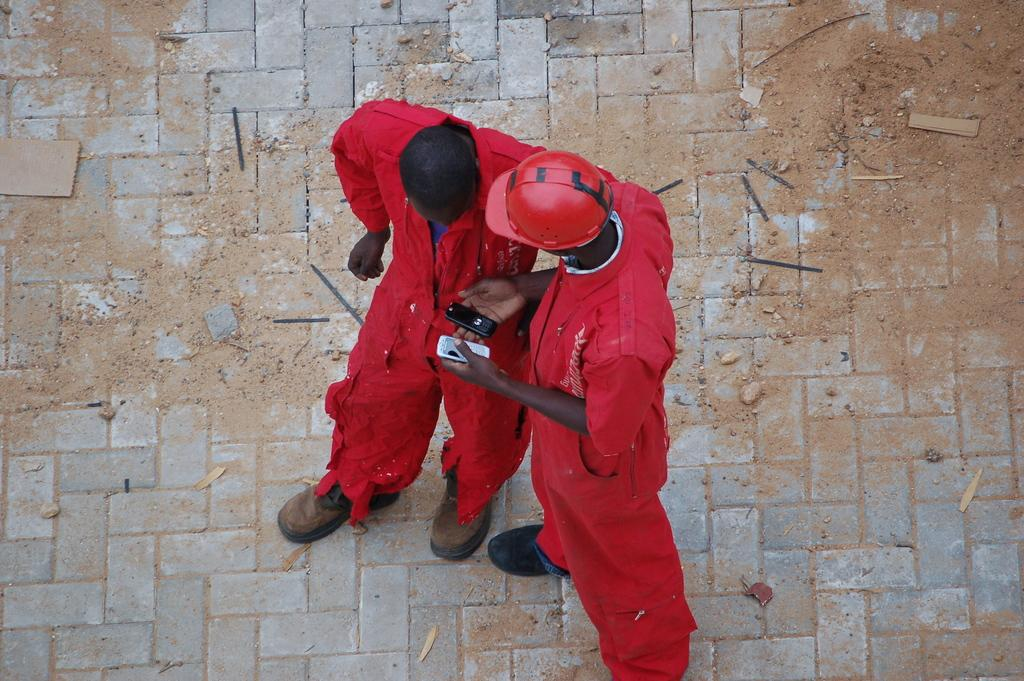How many people are in the image? There are two people in the image. What are the people doing in the image? The people are standing on a surface. Can you describe any objects that one of the people is holding? One person is holding a mobile. What type of protective gear is one of the people wearing? One person is wearing a helmet. What type of bucket can be seen in the alley in the image? There is no bucket or alley present in the image. What type of joke is being told by the person wearing the helmet in the image? There is no joke being told in the image; the person is simply wearing a helmet. 